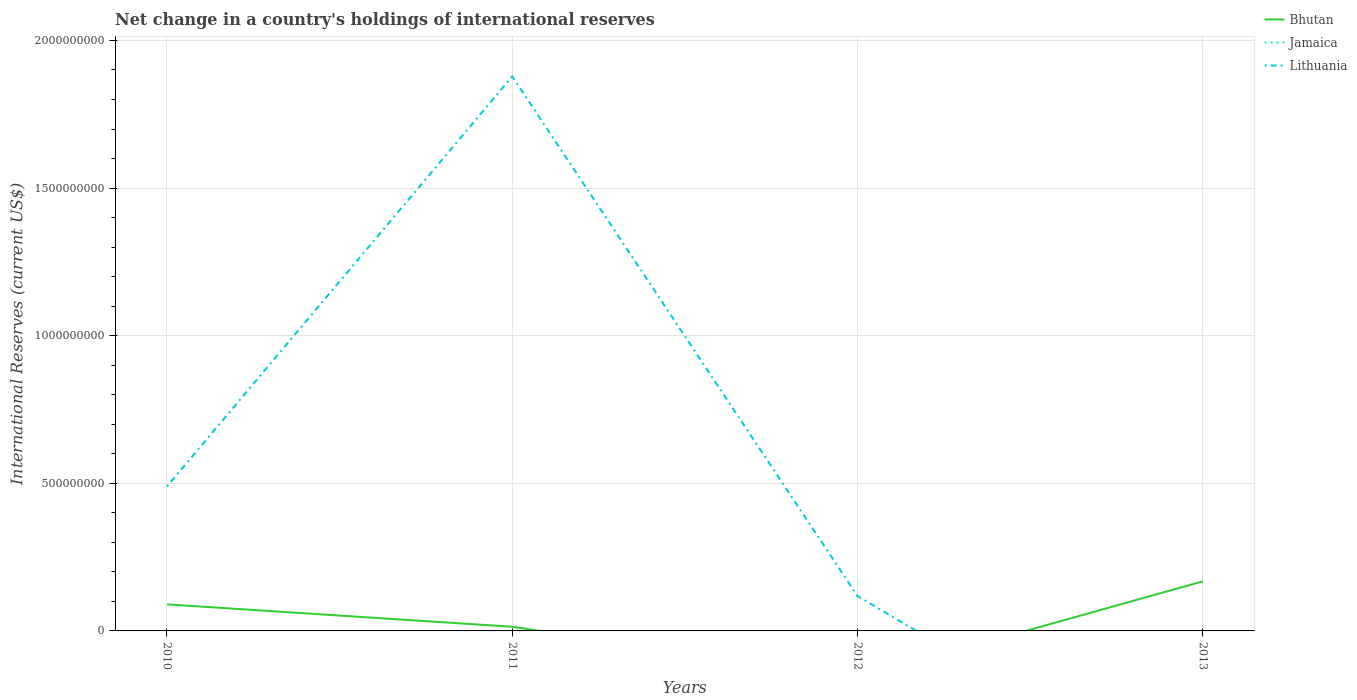How many different coloured lines are there?
Make the answer very short. 2. Across all years, what is the maximum international reserves in Bhutan?
Give a very brief answer. 0. What is the total international reserves in Bhutan in the graph?
Provide a short and direct response. -1.54e+08. What is the difference between the highest and the second highest international reserves in Bhutan?
Keep it short and to the point. 1.68e+08. What is the difference between the highest and the lowest international reserves in Jamaica?
Keep it short and to the point. 0. Is the international reserves in Jamaica strictly greater than the international reserves in Bhutan over the years?
Offer a very short reply. Yes. How many lines are there?
Your answer should be very brief. 2. What is the difference between two consecutive major ticks on the Y-axis?
Provide a short and direct response. 5.00e+08. Are the values on the major ticks of Y-axis written in scientific E-notation?
Ensure brevity in your answer.  No. Does the graph contain any zero values?
Offer a very short reply. Yes. Does the graph contain grids?
Provide a succinct answer. Yes. Where does the legend appear in the graph?
Your answer should be very brief. Top right. How are the legend labels stacked?
Offer a terse response. Vertical. What is the title of the graph?
Your response must be concise. Net change in a country's holdings of international reserves. Does "Myanmar" appear as one of the legend labels in the graph?
Your answer should be very brief. No. What is the label or title of the X-axis?
Provide a succinct answer. Years. What is the label or title of the Y-axis?
Offer a terse response. International Reserves (current US$). What is the International Reserves (current US$) in Bhutan in 2010?
Offer a very short reply. 8.99e+07. What is the International Reserves (current US$) in Lithuania in 2010?
Provide a short and direct response. 4.89e+08. What is the International Reserves (current US$) in Bhutan in 2011?
Make the answer very short. 1.41e+07. What is the International Reserves (current US$) of Jamaica in 2011?
Keep it short and to the point. 0. What is the International Reserves (current US$) of Lithuania in 2011?
Your answer should be compact. 1.88e+09. What is the International Reserves (current US$) of Jamaica in 2012?
Your response must be concise. 0. What is the International Reserves (current US$) in Lithuania in 2012?
Ensure brevity in your answer.  1.18e+08. What is the International Reserves (current US$) of Bhutan in 2013?
Give a very brief answer. 1.68e+08. What is the International Reserves (current US$) of Jamaica in 2013?
Your answer should be compact. 0. Across all years, what is the maximum International Reserves (current US$) of Bhutan?
Offer a very short reply. 1.68e+08. Across all years, what is the maximum International Reserves (current US$) in Lithuania?
Keep it short and to the point. 1.88e+09. Across all years, what is the minimum International Reserves (current US$) in Bhutan?
Your response must be concise. 0. Across all years, what is the minimum International Reserves (current US$) of Lithuania?
Your answer should be compact. 0. What is the total International Reserves (current US$) of Bhutan in the graph?
Provide a succinct answer. 2.72e+08. What is the total International Reserves (current US$) in Lithuania in the graph?
Provide a short and direct response. 2.49e+09. What is the difference between the International Reserves (current US$) of Bhutan in 2010 and that in 2011?
Offer a terse response. 7.58e+07. What is the difference between the International Reserves (current US$) in Lithuania in 2010 and that in 2011?
Provide a short and direct response. -1.39e+09. What is the difference between the International Reserves (current US$) of Lithuania in 2010 and that in 2012?
Your answer should be very brief. 3.71e+08. What is the difference between the International Reserves (current US$) in Bhutan in 2010 and that in 2013?
Offer a terse response. -7.80e+07. What is the difference between the International Reserves (current US$) in Lithuania in 2011 and that in 2012?
Ensure brevity in your answer.  1.76e+09. What is the difference between the International Reserves (current US$) in Bhutan in 2011 and that in 2013?
Offer a terse response. -1.54e+08. What is the difference between the International Reserves (current US$) of Bhutan in 2010 and the International Reserves (current US$) of Lithuania in 2011?
Your answer should be compact. -1.79e+09. What is the difference between the International Reserves (current US$) in Bhutan in 2010 and the International Reserves (current US$) in Lithuania in 2012?
Provide a succinct answer. -2.82e+07. What is the difference between the International Reserves (current US$) in Bhutan in 2011 and the International Reserves (current US$) in Lithuania in 2012?
Your answer should be very brief. -1.04e+08. What is the average International Reserves (current US$) in Bhutan per year?
Provide a short and direct response. 6.80e+07. What is the average International Reserves (current US$) in Lithuania per year?
Provide a succinct answer. 6.21e+08. In the year 2010, what is the difference between the International Reserves (current US$) in Bhutan and International Reserves (current US$) in Lithuania?
Ensure brevity in your answer.  -4.00e+08. In the year 2011, what is the difference between the International Reserves (current US$) in Bhutan and International Reserves (current US$) in Lithuania?
Offer a terse response. -1.86e+09. What is the ratio of the International Reserves (current US$) in Bhutan in 2010 to that in 2011?
Your answer should be compact. 6.37. What is the ratio of the International Reserves (current US$) in Lithuania in 2010 to that in 2011?
Your answer should be very brief. 0.26. What is the ratio of the International Reserves (current US$) in Lithuania in 2010 to that in 2012?
Ensure brevity in your answer.  4.14. What is the ratio of the International Reserves (current US$) in Bhutan in 2010 to that in 2013?
Your answer should be compact. 0.54. What is the ratio of the International Reserves (current US$) in Lithuania in 2011 to that in 2012?
Offer a terse response. 15.9. What is the ratio of the International Reserves (current US$) of Bhutan in 2011 to that in 2013?
Your response must be concise. 0.08. What is the difference between the highest and the second highest International Reserves (current US$) of Bhutan?
Make the answer very short. 7.80e+07. What is the difference between the highest and the second highest International Reserves (current US$) of Lithuania?
Your answer should be compact. 1.39e+09. What is the difference between the highest and the lowest International Reserves (current US$) in Bhutan?
Provide a succinct answer. 1.68e+08. What is the difference between the highest and the lowest International Reserves (current US$) in Lithuania?
Offer a very short reply. 1.88e+09. 